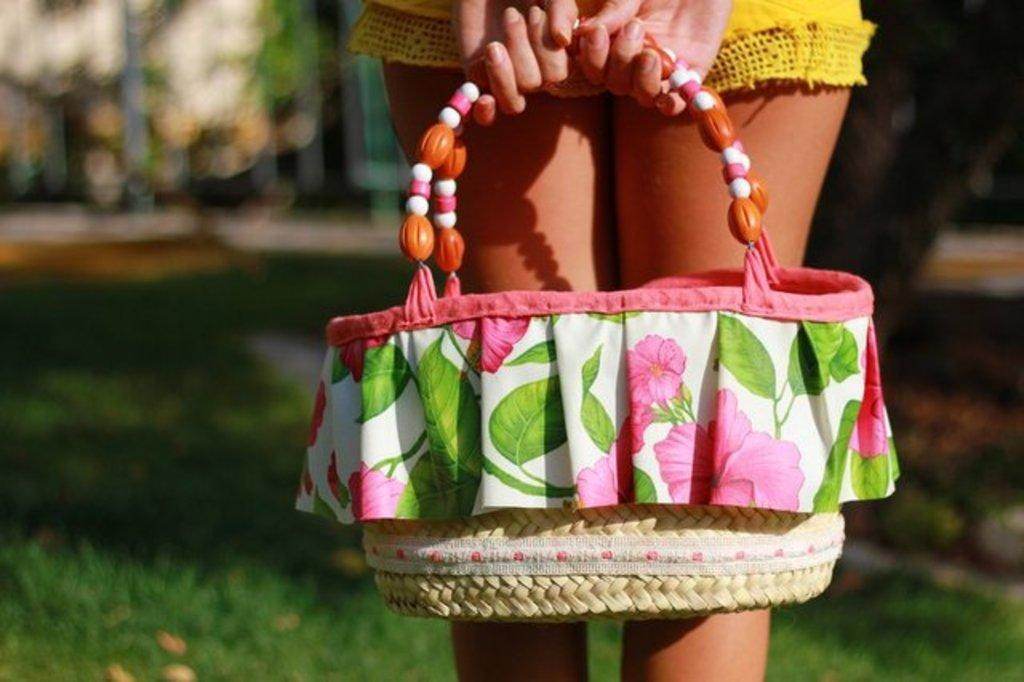Who or what is present in the image? There is a person in the image. What is the person holding in the image? The person is holding a bag with her hands. What type of surface can be seen in the image? There is grass in the image. What type of mark can be seen on the person's face in the image? There is no mark visible on the person's face in the image. 